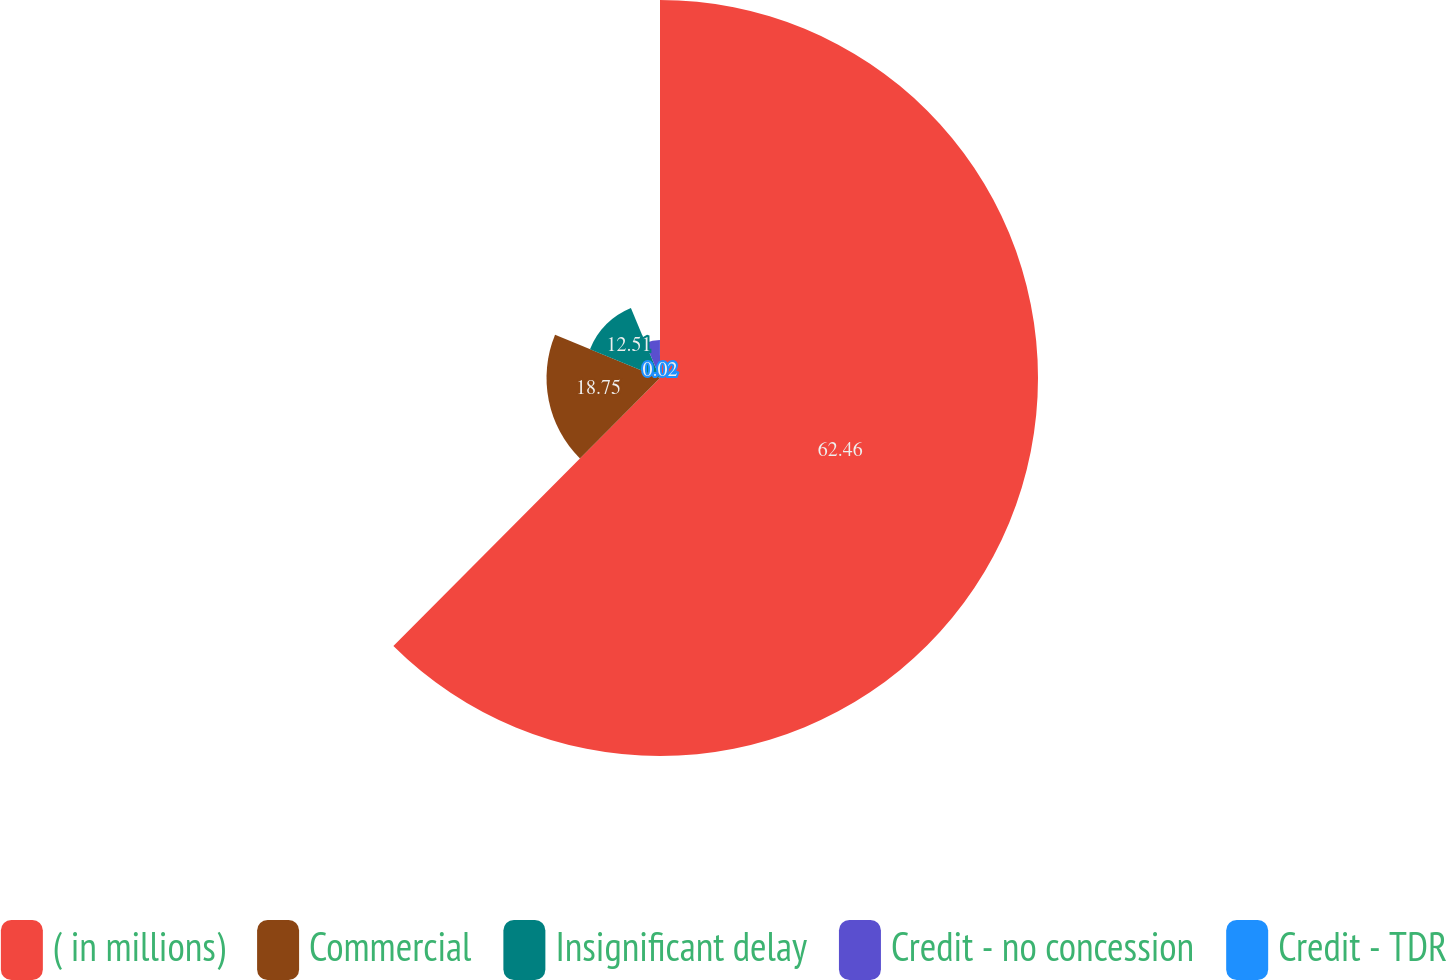Convert chart to OTSL. <chart><loc_0><loc_0><loc_500><loc_500><pie_chart><fcel>( in millions)<fcel>Commercial<fcel>Insignificant delay<fcel>Credit - no concession<fcel>Credit - TDR<nl><fcel>62.46%<fcel>18.75%<fcel>12.51%<fcel>6.26%<fcel>0.02%<nl></chart> 